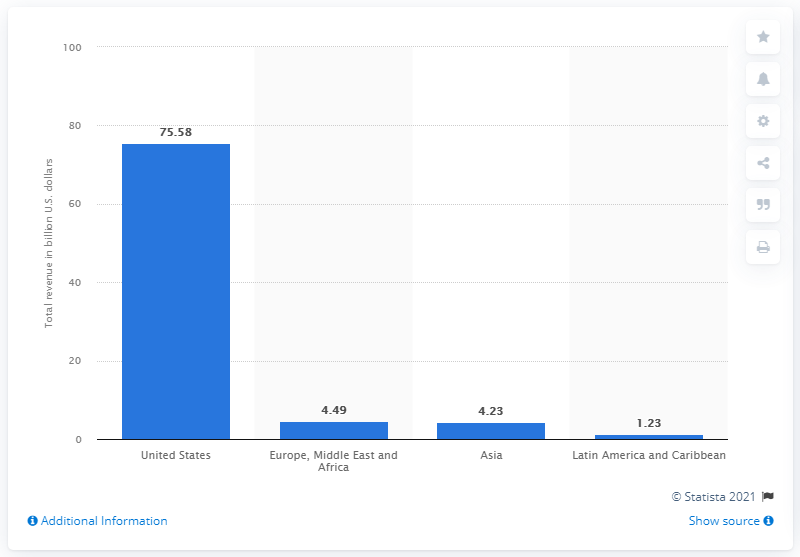Identify some key points in this picture. In 2020, the Bank of America generated a total revenue of approximately 75.58 billion dollars in the United States. 